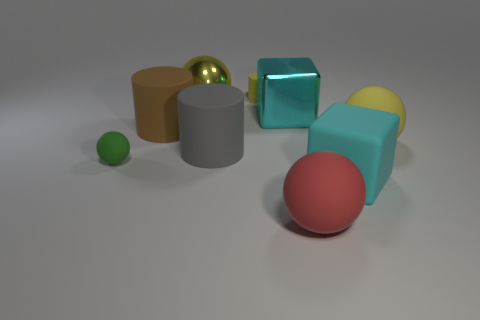Is the color of the tiny rubber thing that is on the left side of the tiny yellow object the same as the large matte sphere behind the big red ball?
Provide a succinct answer. No. Is the shape of the cyan metal thing the same as the brown rubber object?
Give a very brief answer. No. Are there any other things that have the same shape as the big brown object?
Provide a succinct answer. Yes. Is the material of the large yellow sphere that is to the right of the big metallic cube the same as the large gray object?
Give a very brief answer. Yes. What is the shape of the large object that is both left of the big gray cylinder and in front of the large metal ball?
Provide a succinct answer. Cylinder. Are there any red matte spheres to the left of the big metallic object on the right side of the tiny cylinder?
Ensure brevity in your answer.  No. How many other things are there of the same material as the small yellow thing?
Your response must be concise. 6. Does the cyan object left of the cyan matte object have the same shape as the small object that is in front of the big gray rubber cylinder?
Ensure brevity in your answer.  No. Is the red thing made of the same material as the small cylinder?
Keep it short and to the point. Yes. What size is the yellow rubber object that is behind the yellow sphere that is on the right side of the small rubber object right of the tiny sphere?
Keep it short and to the point. Small. 